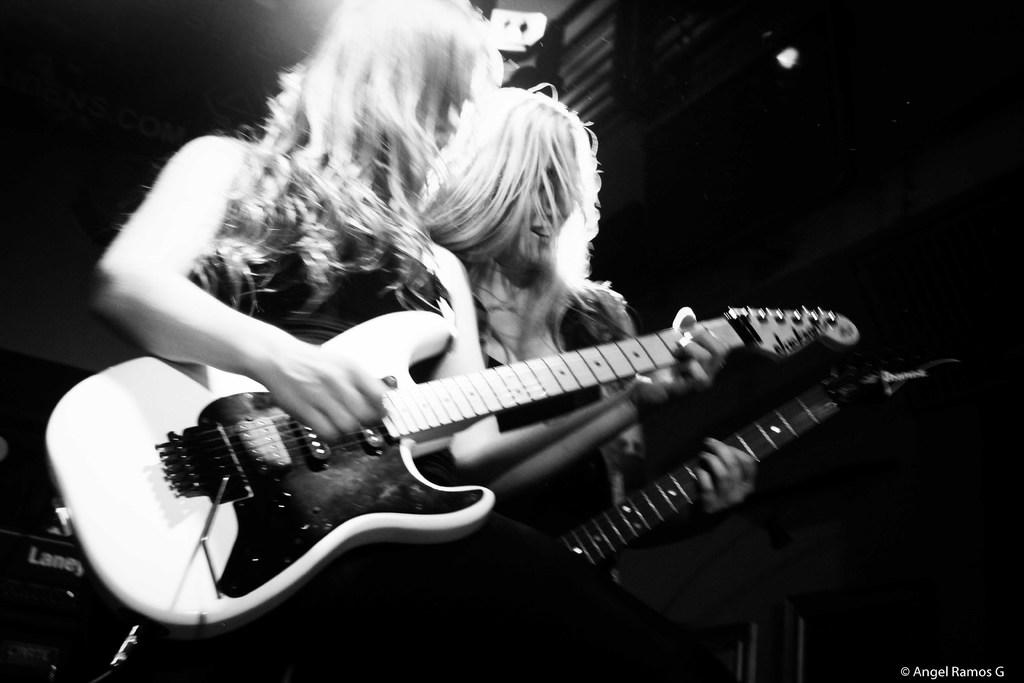How many people are in the image? There are two persons in the image. What are the two persons doing in the image? Both persons are playing guitar. How many clovers can be seen growing between the two guitar players in the image? There are no clovers visible in the image; it features two persons playing guitar. Are the two guitar players sisters in the image? There is no information provided about the relationship between the two guitar players in the image. 